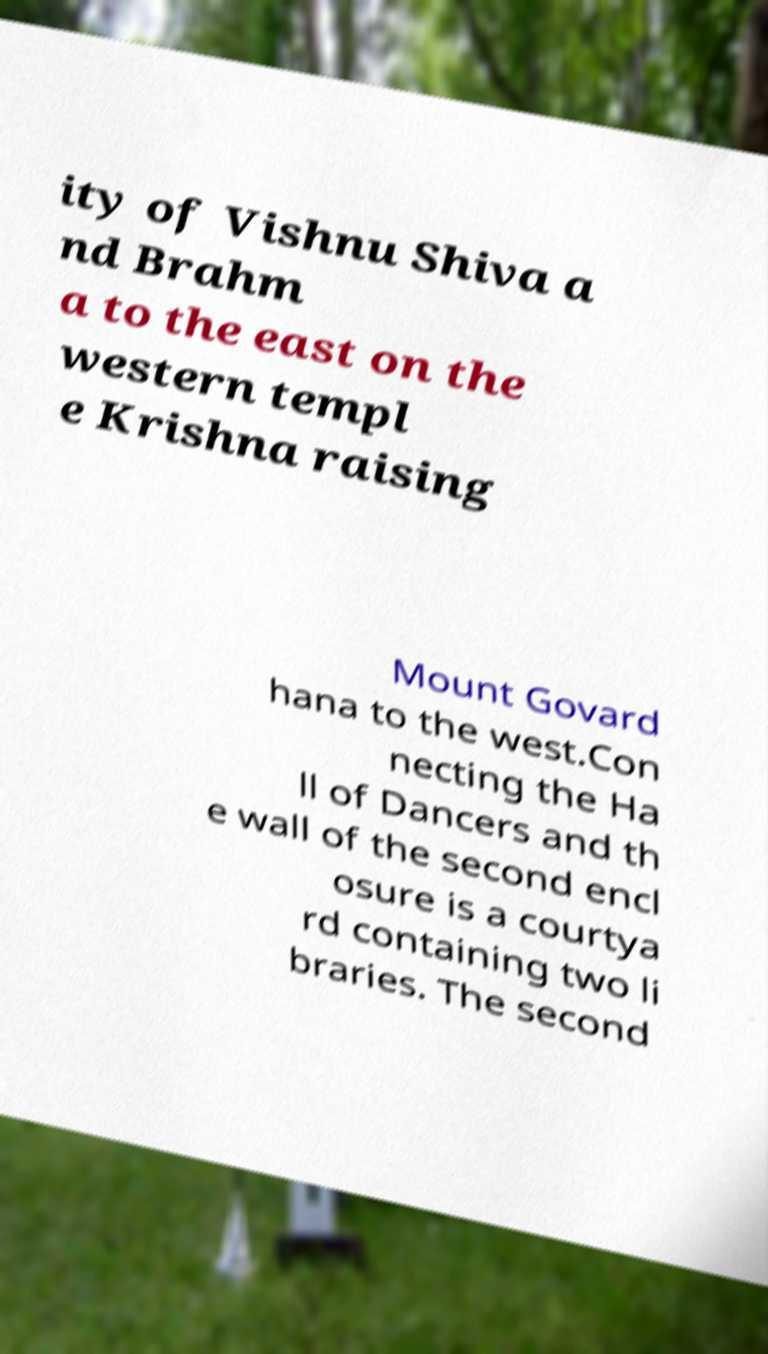I need the written content from this picture converted into text. Can you do that? ity of Vishnu Shiva a nd Brahm a to the east on the western templ e Krishna raising Mount Govard hana to the west.Con necting the Ha ll of Dancers and th e wall of the second encl osure is a courtya rd containing two li braries. The second 